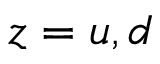Convert formula to latex. <formula><loc_0><loc_0><loc_500><loc_500>z = u , d</formula> 